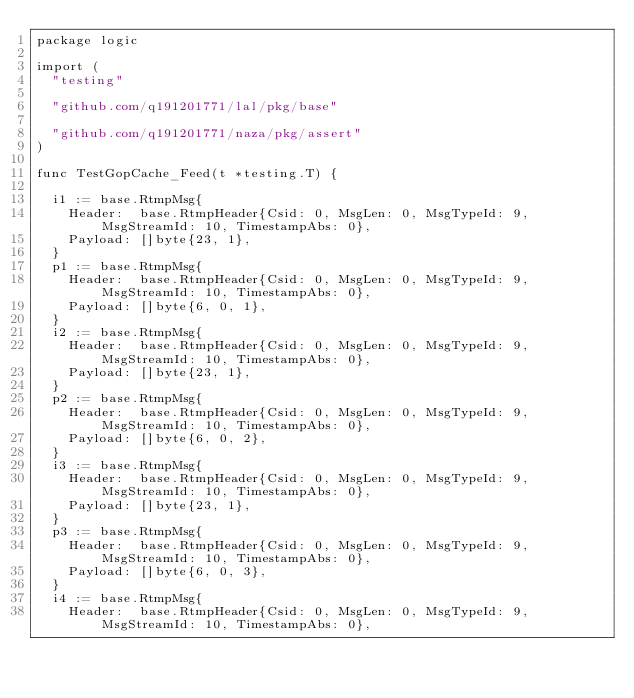Convert code to text. <code><loc_0><loc_0><loc_500><loc_500><_Go_>package logic

import (
	"testing"

	"github.com/q191201771/lal/pkg/base"

	"github.com/q191201771/naza/pkg/assert"
)

func TestGopCache_Feed(t *testing.T) {

	i1 := base.RtmpMsg{
		Header:  base.RtmpHeader{Csid: 0, MsgLen: 0, MsgTypeId: 9, MsgStreamId: 10, TimestampAbs: 0},
		Payload: []byte{23, 1},
	}
	p1 := base.RtmpMsg{
		Header:  base.RtmpHeader{Csid: 0, MsgLen: 0, MsgTypeId: 9, MsgStreamId: 10, TimestampAbs: 0},
		Payload: []byte{6, 0, 1},
	}
	i2 := base.RtmpMsg{
		Header:  base.RtmpHeader{Csid: 0, MsgLen: 0, MsgTypeId: 9, MsgStreamId: 10, TimestampAbs: 0},
		Payload: []byte{23, 1},
	}
	p2 := base.RtmpMsg{
		Header:  base.RtmpHeader{Csid: 0, MsgLen: 0, MsgTypeId: 9, MsgStreamId: 10, TimestampAbs: 0},
		Payload: []byte{6, 0, 2},
	}
	i3 := base.RtmpMsg{
		Header:  base.RtmpHeader{Csid: 0, MsgLen: 0, MsgTypeId: 9, MsgStreamId: 10, TimestampAbs: 0},
		Payload: []byte{23, 1},
	}
	p3 := base.RtmpMsg{
		Header:  base.RtmpHeader{Csid: 0, MsgLen: 0, MsgTypeId: 9, MsgStreamId: 10, TimestampAbs: 0},
		Payload: []byte{6, 0, 3},
	}
	i4 := base.RtmpMsg{
		Header:  base.RtmpHeader{Csid: 0, MsgLen: 0, MsgTypeId: 9, MsgStreamId: 10, TimestampAbs: 0},</code> 